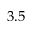<formula> <loc_0><loc_0><loc_500><loc_500>3 . 5</formula> 